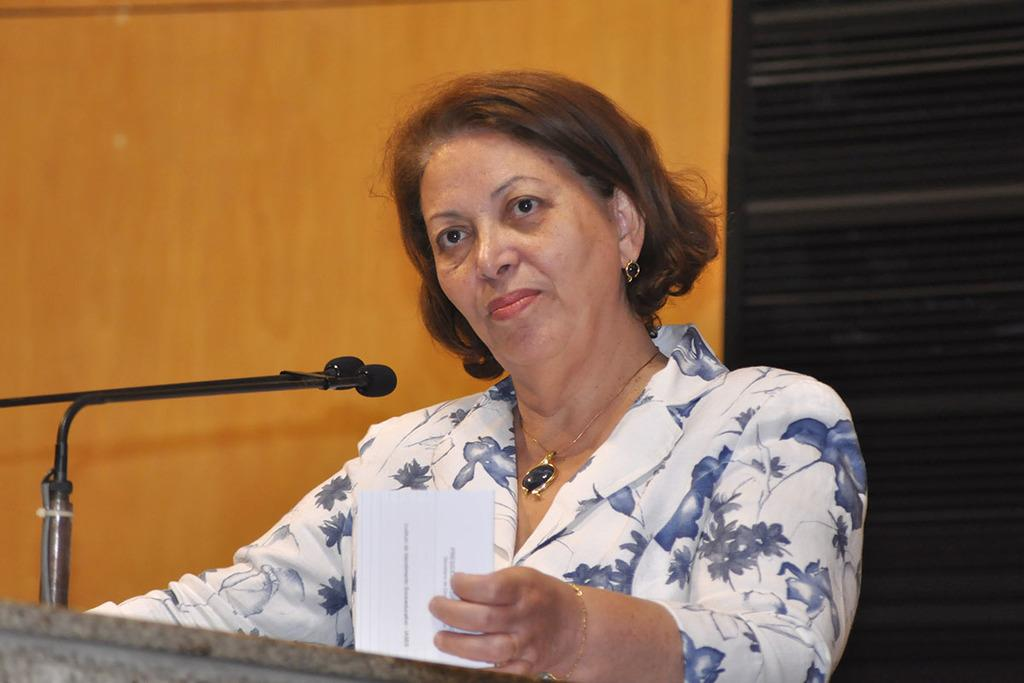Who is the main subject in the image? There is a lady in the image. What is the lady holding in the image? The lady is holding a paper. What animals can be seen in front of the lady? There are mice in front of the lady. What is visible behind the lady? There is a wall behind the lady. What type of engine can be seen in the image? There is no engine present in the image. How does the lady's heart appear in the image? The lady's heart is not visible in the image. 